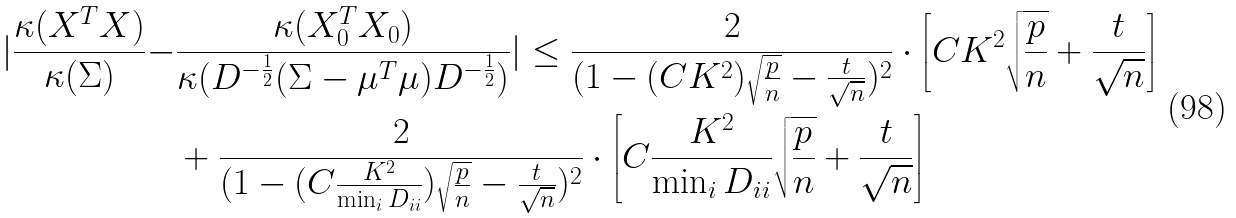<formula> <loc_0><loc_0><loc_500><loc_500>| \frac { \kappa ( X ^ { T } X ) } { \kappa ( \Sigma ) } - & \frac { \kappa ( X _ { 0 } ^ { T } X _ { 0 } ) } { \kappa ( D ^ { - \frac { 1 } { 2 } } ( \Sigma - \mu ^ { T } \mu ) D ^ { - \frac { 1 } { 2 } } ) } | \leq \frac { 2 } { ( 1 - ( C K ^ { 2 } ) \sqrt { \frac { p } { n } } - \frac { t } { \sqrt { n } } ) ^ { 2 } } \cdot \left [ C K ^ { 2 } \sqrt { \frac { p } { n } } + \frac { t } { \sqrt { n } } \right ] \\ & + \frac { 2 } { ( 1 - ( C \frac { K ^ { 2 } } { \min _ { i } D _ { i i } } ) \sqrt { \frac { p } { n } } - \frac { t } { \sqrt { n } } ) ^ { 2 } } \cdot \left [ C \frac { K ^ { 2 } } { \min _ { i } D _ { i i } } \sqrt { \frac { p } { n } } + \frac { t } { \sqrt { n } } \right ]</formula> 